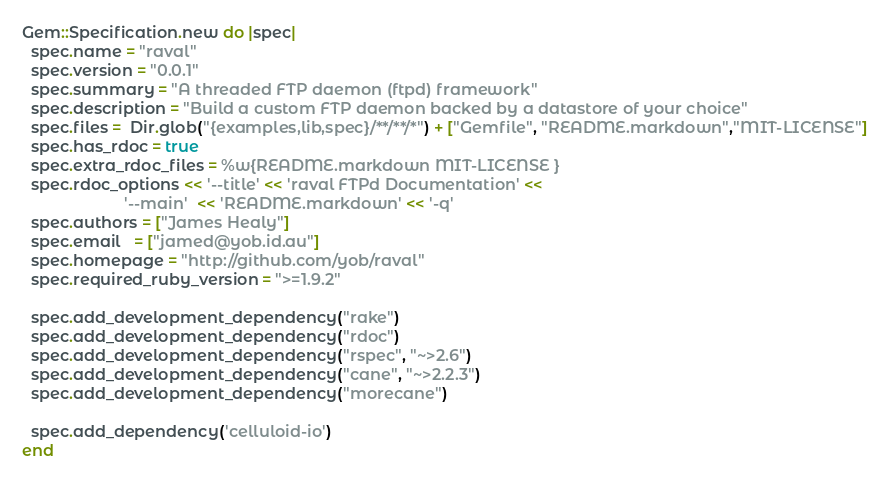<code> <loc_0><loc_0><loc_500><loc_500><_Ruby_>Gem::Specification.new do |spec|
  spec.name = "raval"
  spec.version = "0.0.1"
  spec.summary = "A threaded FTP daemon (ftpd) framework"
  spec.description = "Build a custom FTP daemon backed by a datastore of your choice"
  spec.files =  Dir.glob("{examples,lib,spec}/**/**/*") + ["Gemfile", "README.markdown","MIT-LICENSE"]
  spec.has_rdoc = true
  spec.extra_rdoc_files = %w{README.markdown MIT-LICENSE }
  spec.rdoc_options << '--title' << 'raval FTPd Documentation' <<
                       '--main'  << 'README.markdown' << '-q'
  spec.authors = ["James Healy"]
  spec.email   = ["jamed@yob.id.au"]
  spec.homepage = "http://github.com/yob/raval"
  spec.required_ruby_version = ">=1.9.2"

  spec.add_development_dependency("rake")
  spec.add_development_dependency("rdoc")
  spec.add_development_dependency("rspec", "~>2.6")
  spec.add_development_dependency("cane", "~>2.2.3")
  spec.add_development_dependency("morecane")

  spec.add_dependency('celluloid-io')
end
</code> 